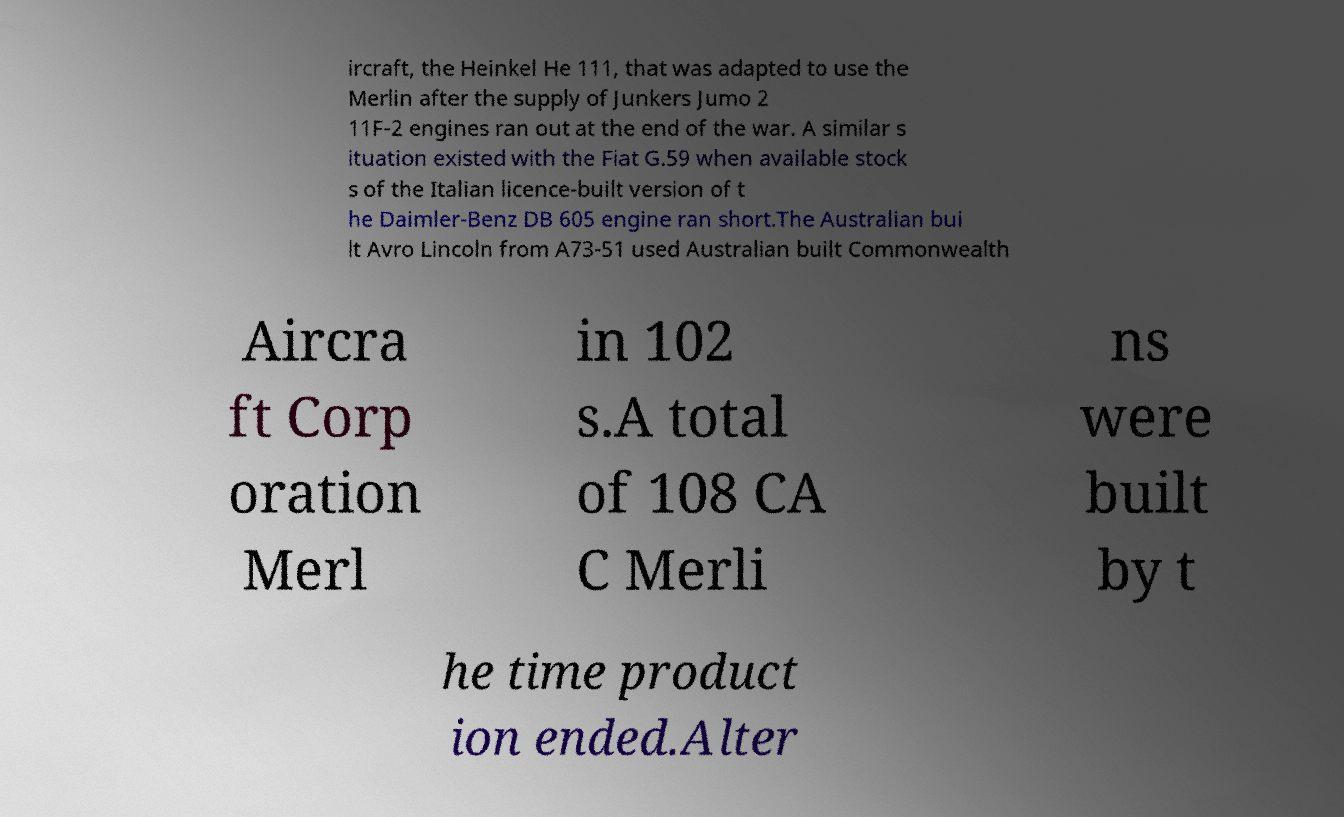Can you read and provide the text displayed in the image?This photo seems to have some interesting text. Can you extract and type it out for me? ircraft, the Heinkel He 111, that was adapted to use the Merlin after the supply of Junkers Jumo 2 11F-2 engines ran out at the end of the war. A similar s ituation existed with the Fiat G.59 when available stock s of the Italian licence-built version of t he Daimler-Benz DB 605 engine ran short.The Australian bui lt Avro Lincoln from A73-51 used Australian built Commonwealth Aircra ft Corp oration Merl in 102 s.A total of 108 CA C Merli ns were built by t he time product ion ended.Alter 